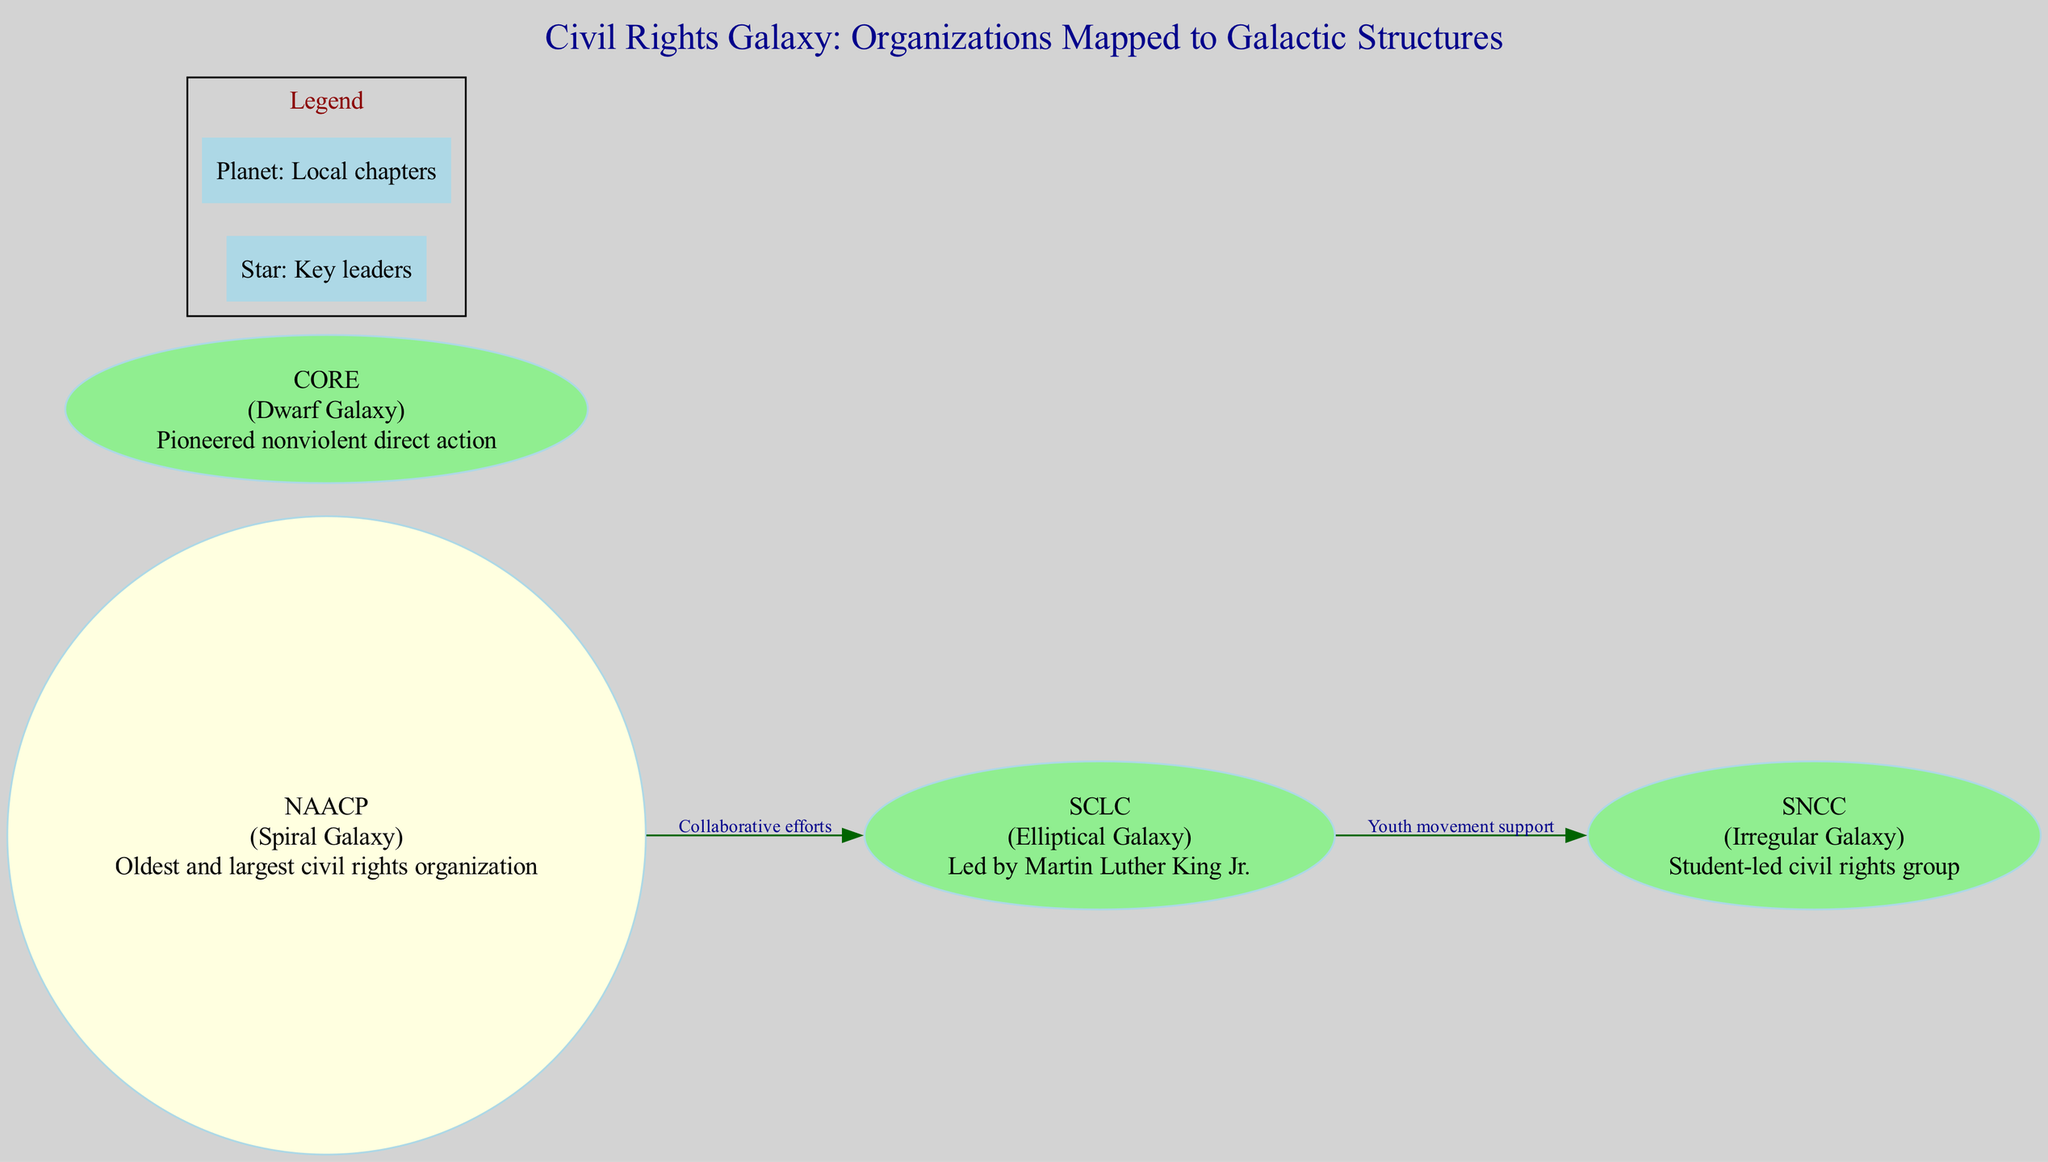What is the name of the oldest civil rights organization? The diagram indicates that the NAACP is the oldest civil rights organization, which is categorized under the Spiral Galaxy.
Answer: NAACP Which civil rights organization is associated with Martin Luther King Jr.? The diagram shows that the SCLC, which is an Elliptical Galaxy, is led by Martin Luther King Jr.
Answer: SCLC How many nodes are present in the diagram? The diagram lists four galactic structures (NAACP, SCLC, SNCC, CORE) which represent the civil rights organizations, making it a total of four nodes.
Answer: 4 What type of galaxy is the SNCC classified as? According to the diagram, the SNCC is categorized as an Irregular Galaxy, indicating its unique structure compared to the others.
Answer: Irregular Galaxy What is the relationship between NAACP and SCLC? The diagram specifies a collaborative efforts connection from NAACP to SCLC, indicating a direct relationship between them in their civil rights endeavors.
Answer: Collaborative efforts Which organization is noted for pioneering nonviolent direct action? CORE is highlighted in the diagram as the organization that pioneered nonviolent direct action, categorized as a Dwarf Galaxy.
Answer: CORE How do SCLC and SNCC interact in the diagram? The diagram illustrates that SCLC supports the youth movement represented by SNCC, indicating an influence from SCLC towards the younger activists in SNCC.
Answer: Youth movement support What does a star represent in the legend? The legend in the diagram states that a star symbolizes key leaders, indicating the importance of these individuals in the civil rights organizations.
Answer: Key leaders How many connections are there in the diagram? The diagram indicates that there are two connections, one from NAACP to SCLC and another from SCLC to SNCC, totaling to two connections.
Answer: 2 